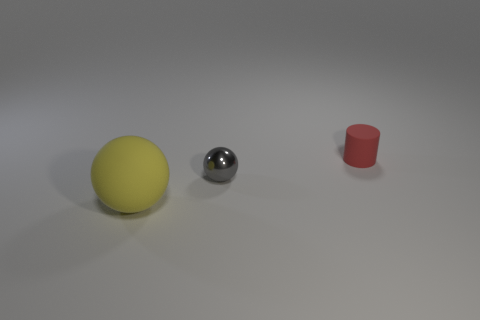Add 3 small matte things. How many objects exist? 6 Subtract all spheres. How many objects are left? 1 Subtract 1 yellow balls. How many objects are left? 2 Subtract all large matte spheres. Subtract all red things. How many objects are left? 1 Add 3 red things. How many red things are left? 4 Add 3 yellow rubber cubes. How many yellow rubber cubes exist? 3 